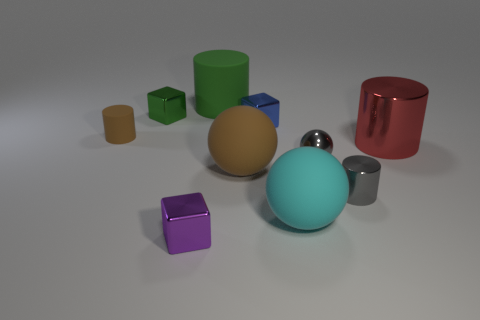Subtract all green blocks. How many blocks are left? 2 Subtract 3 cylinders. How many cylinders are left? 1 Subtract all purple blocks. How many blocks are left? 2 Subtract all balls. How many objects are left? 7 Add 7 big green rubber cylinders. How many big green rubber cylinders exist? 8 Subtract 1 cyan balls. How many objects are left? 9 Subtract all purple balls. Subtract all cyan cylinders. How many balls are left? 3 Subtract all green spheres. How many brown cylinders are left? 1 Subtract all red cylinders. Subtract all matte spheres. How many objects are left? 7 Add 1 small brown rubber cylinders. How many small brown rubber cylinders are left? 2 